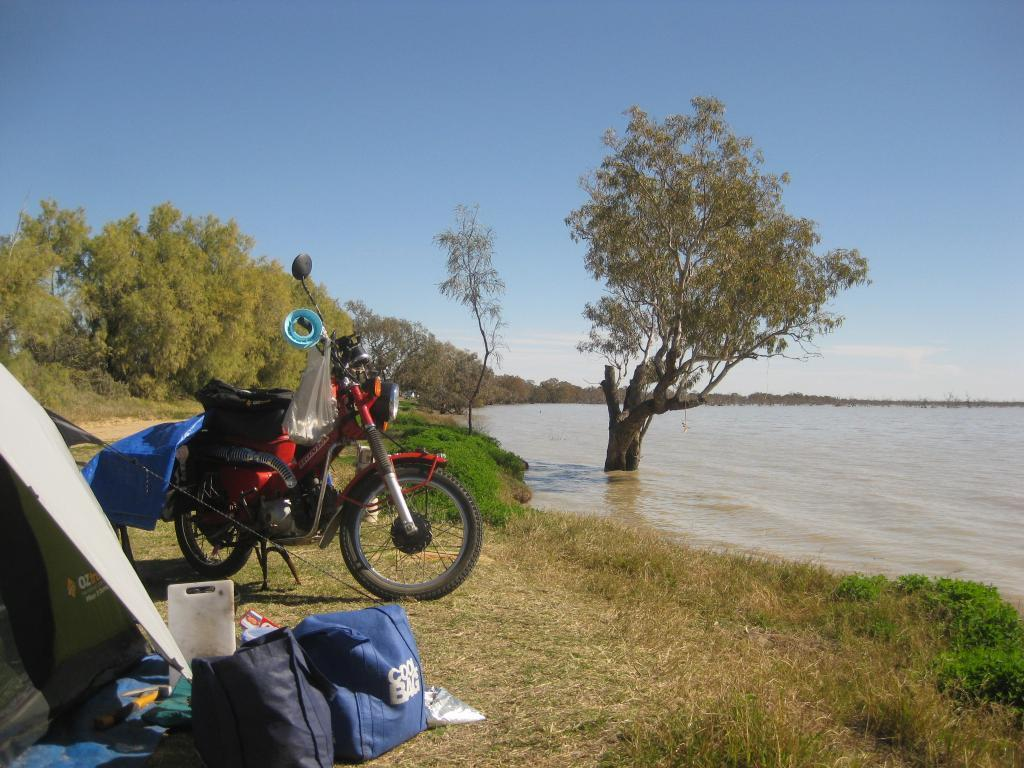What type of vegetation is present in the image? There is grass in the image. What objects can be seen in the image besides the grass? There are bags and a red-colored vehicle in the image. Can you describe the unspecified things in the front of the image? Unfortunately, the facts do not provide enough information to describe the unspecified things in the front of the image. What can be seen in the background of the image? In the background of the image, there is water, trees, clouds, and the sky. What historical event is being commemorated by the scale in the image? There is no scale present in the image, and therefore no historical event can be associated with it. 